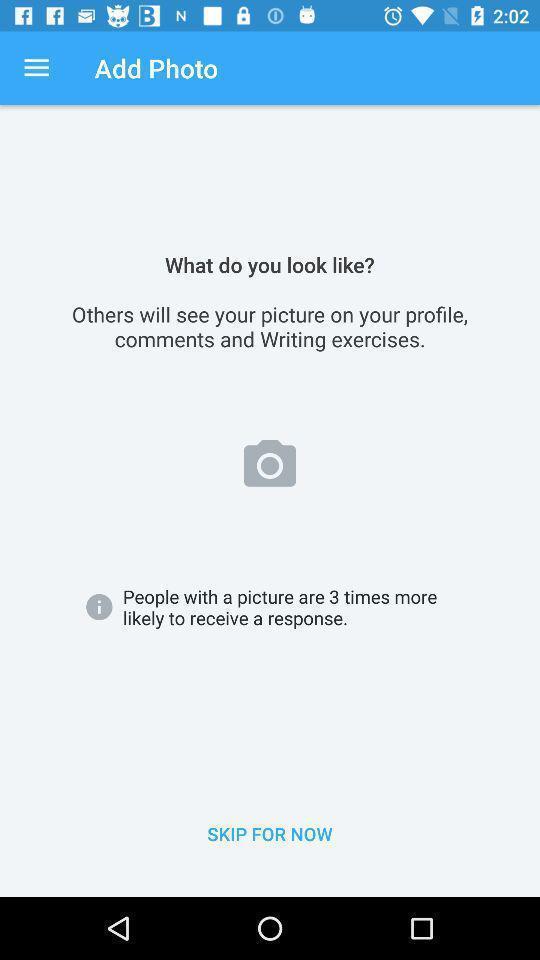Summarize the information in this screenshot. Page to add a picture. 